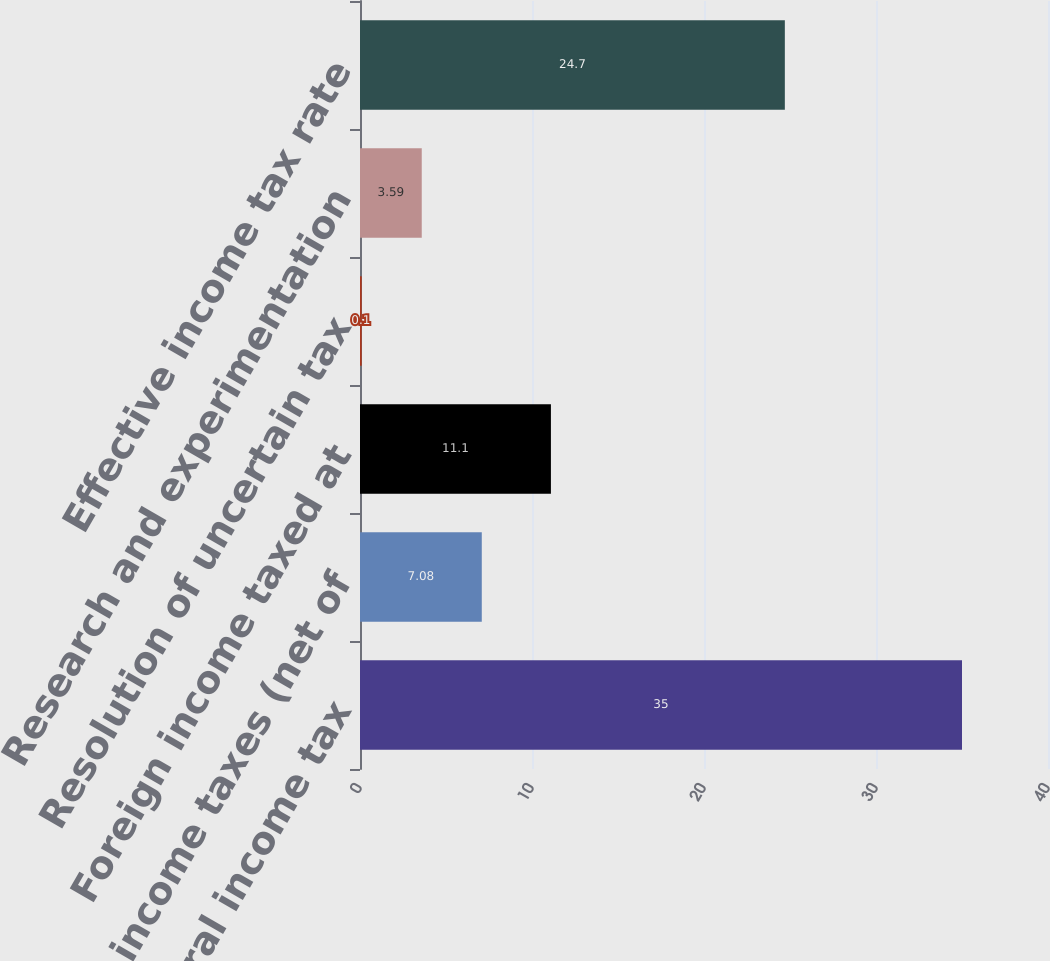Convert chart to OTSL. <chart><loc_0><loc_0><loc_500><loc_500><bar_chart><fcel>Statutory federal income tax<fcel>State income taxes (net of<fcel>Foreign income taxed at<fcel>Resolution of uncertain tax<fcel>Research and experimentation<fcel>Effective income tax rate<nl><fcel>35<fcel>7.08<fcel>11.1<fcel>0.1<fcel>3.59<fcel>24.7<nl></chart> 